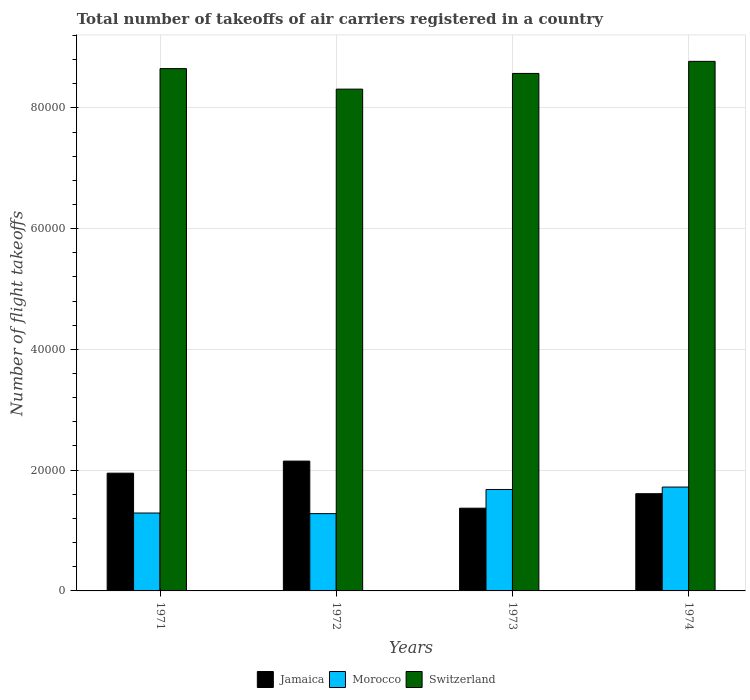How many groups of bars are there?
Provide a short and direct response. 4. Are the number of bars on each tick of the X-axis equal?
Provide a short and direct response. Yes. How many bars are there on the 2nd tick from the right?
Make the answer very short. 3. What is the label of the 2nd group of bars from the left?
Ensure brevity in your answer.  1972. What is the total number of flight takeoffs in Switzerland in 1972?
Offer a terse response. 8.31e+04. Across all years, what is the maximum total number of flight takeoffs in Morocco?
Give a very brief answer. 1.72e+04. Across all years, what is the minimum total number of flight takeoffs in Morocco?
Provide a succinct answer. 1.28e+04. In which year was the total number of flight takeoffs in Morocco maximum?
Provide a succinct answer. 1974. In which year was the total number of flight takeoffs in Jamaica minimum?
Your answer should be compact. 1973. What is the total total number of flight takeoffs in Morocco in the graph?
Offer a terse response. 5.97e+04. What is the difference between the total number of flight takeoffs in Morocco in 1971 and that in 1974?
Keep it short and to the point. -4300. What is the difference between the total number of flight takeoffs in Jamaica in 1974 and the total number of flight takeoffs in Switzerland in 1971?
Provide a succinct answer. -7.04e+04. What is the average total number of flight takeoffs in Jamaica per year?
Your answer should be compact. 1.77e+04. In the year 1971, what is the difference between the total number of flight takeoffs in Switzerland and total number of flight takeoffs in Jamaica?
Give a very brief answer. 6.70e+04. In how many years, is the total number of flight takeoffs in Switzerland greater than 8000?
Your answer should be compact. 4. What is the ratio of the total number of flight takeoffs in Jamaica in 1971 to that in 1974?
Your response must be concise. 1.21. Is the difference between the total number of flight takeoffs in Switzerland in 1971 and 1972 greater than the difference between the total number of flight takeoffs in Jamaica in 1971 and 1972?
Keep it short and to the point. Yes. What is the difference between the highest and the second highest total number of flight takeoffs in Switzerland?
Provide a succinct answer. 1200. What is the difference between the highest and the lowest total number of flight takeoffs in Jamaica?
Offer a very short reply. 7800. Is the sum of the total number of flight takeoffs in Morocco in 1971 and 1974 greater than the maximum total number of flight takeoffs in Jamaica across all years?
Your answer should be very brief. Yes. What does the 2nd bar from the left in 1974 represents?
Your answer should be very brief. Morocco. What does the 2nd bar from the right in 1971 represents?
Provide a succinct answer. Morocco. Is it the case that in every year, the sum of the total number of flight takeoffs in Switzerland and total number of flight takeoffs in Jamaica is greater than the total number of flight takeoffs in Morocco?
Your answer should be very brief. Yes. Are all the bars in the graph horizontal?
Make the answer very short. No. How many years are there in the graph?
Offer a terse response. 4. What is the difference between two consecutive major ticks on the Y-axis?
Ensure brevity in your answer.  2.00e+04. Does the graph contain any zero values?
Your response must be concise. No. Does the graph contain grids?
Offer a very short reply. Yes. How are the legend labels stacked?
Your answer should be compact. Horizontal. What is the title of the graph?
Make the answer very short. Total number of takeoffs of air carriers registered in a country. Does "Mongolia" appear as one of the legend labels in the graph?
Give a very brief answer. No. What is the label or title of the X-axis?
Keep it short and to the point. Years. What is the label or title of the Y-axis?
Keep it short and to the point. Number of flight takeoffs. What is the Number of flight takeoffs in Jamaica in 1971?
Offer a very short reply. 1.95e+04. What is the Number of flight takeoffs in Morocco in 1971?
Make the answer very short. 1.29e+04. What is the Number of flight takeoffs of Switzerland in 1971?
Offer a terse response. 8.65e+04. What is the Number of flight takeoffs in Jamaica in 1972?
Offer a very short reply. 2.15e+04. What is the Number of flight takeoffs in Morocco in 1972?
Make the answer very short. 1.28e+04. What is the Number of flight takeoffs of Switzerland in 1972?
Your answer should be very brief. 8.31e+04. What is the Number of flight takeoffs in Jamaica in 1973?
Ensure brevity in your answer.  1.37e+04. What is the Number of flight takeoffs in Morocco in 1973?
Your answer should be compact. 1.68e+04. What is the Number of flight takeoffs of Switzerland in 1973?
Your response must be concise. 8.57e+04. What is the Number of flight takeoffs of Jamaica in 1974?
Provide a short and direct response. 1.61e+04. What is the Number of flight takeoffs in Morocco in 1974?
Your answer should be compact. 1.72e+04. What is the Number of flight takeoffs of Switzerland in 1974?
Make the answer very short. 8.77e+04. Across all years, what is the maximum Number of flight takeoffs of Jamaica?
Ensure brevity in your answer.  2.15e+04. Across all years, what is the maximum Number of flight takeoffs of Morocco?
Give a very brief answer. 1.72e+04. Across all years, what is the maximum Number of flight takeoffs of Switzerland?
Offer a very short reply. 8.77e+04. Across all years, what is the minimum Number of flight takeoffs in Jamaica?
Provide a short and direct response. 1.37e+04. Across all years, what is the minimum Number of flight takeoffs of Morocco?
Offer a terse response. 1.28e+04. Across all years, what is the minimum Number of flight takeoffs of Switzerland?
Make the answer very short. 8.31e+04. What is the total Number of flight takeoffs of Jamaica in the graph?
Give a very brief answer. 7.08e+04. What is the total Number of flight takeoffs of Morocco in the graph?
Make the answer very short. 5.97e+04. What is the total Number of flight takeoffs of Switzerland in the graph?
Keep it short and to the point. 3.43e+05. What is the difference between the Number of flight takeoffs in Jamaica in 1971 and that in 1972?
Your answer should be very brief. -2000. What is the difference between the Number of flight takeoffs in Morocco in 1971 and that in 1972?
Ensure brevity in your answer.  100. What is the difference between the Number of flight takeoffs in Switzerland in 1971 and that in 1972?
Keep it short and to the point. 3400. What is the difference between the Number of flight takeoffs of Jamaica in 1971 and that in 1973?
Offer a terse response. 5800. What is the difference between the Number of flight takeoffs in Morocco in 1971 and that in 1973?
Keep it short and to the point. -3900. What is the difference between the Number of flight takeoffs in Switzerland in 1971 and that in 1973?
Provide a succinct answer. 800. What is the difference between the Number of flight takeoffs in Jamaica in 1971 and that in 1974?
Your answer should be very brief. 3400. What is the difference between the Number of flight takeoffs of Morocco in 1971 and that in 1974?
Keep it short and to the point. -4300. What is the difference between the Number of flight takeoffs of Switzerland in 1971 and that in 1974?
Make the answer very short. -1200. What is the difference between the Number of flight takeoffs of Jamaica in 1972 and that in 1973?
Make the answer very short. 7800. What is the difference between the Number of flight takeoffs of Morocco in 1972 and that in 1973?
Ensure brevity in your answer.  -4000. What is the difference between the Number of flight takeoffs of Switzerland in 1972 and that in 1973?
Keep it short and to the point. -2600. What is the difference between the Number of flight takeoffs in Jamaica in 1972 and that in 1974?
Keep it short and to the point. 5400. What is the difference between the Number of flight takeoffs in Morocco in 1972 and that in 1974?
Make the answer very short. -4400. What is the difference between the Number of flight takeoffs of Switzerland in 1972 and that in 1974?
Give a very brief answer. -4600. What is the difference between the Number of flight takeoffs of Jamaica in 1973 and that in 1974?
Provide a short and direct response. -2400. What is the difference between the Number of flight takeoffs of Morocco in 1973 and that in 1974?
Provide a short and direct response. -400. What is the difference between the Number of flight takeoffs in Switzerland in 1973 and that in 1974?
Ensure brevity in your answer.  -2000. What is the difference between the Number of flight takeoffs in Jamaica in 1971 and the Number of flight takeoffs in Morocco in 1972?
Give a very brief answer. 6700. What is the difference between the Number of flight takeoffs of Jamaica in 1971 and the Number of flight takeoffs of Switzerland in 1972?
Give a very brief answer. -6.36e+04. What is the difference between the Number of flight takeoffs of Morocco in 1971 and the Number of flight takeoffs of Switzerland in 1972?
Offer a very short reply. -7.02e+04. What is the difference between the Number of flight takeoffs in Jamaica in 1971 and the Number of flight takeoffs in Morocco in 1973?
Your answer should be compact. 2700. What is the difference between the Number of flight takeoffs in Jamaica in 1971 and the Number of flight takeoffs in Switzerland in 1973?
Offer a terse response. -6.62e+04. What is the difference between the Number of flight takeoffs of Morocco in 1971 and the Number of flight takeoffs of Switzerland in 1973?
Offer a very short reply. -7.28e+04. What is the difference between the Number of flight takeoffs in Jamaica in 1971 and the Number of flight takeoffs in Morocco in 1974?
Provide a succinct answer. 2300. What is the difference between the Number of flight takeoffs of Jamaica in 1971 and the Number of flight takeoffs of Switzerland in 1974?
Provide a short and direct response. -6.82e+04. What is the difference between the Number of flight takeoffs of Morocco in 1971 and the Number of flight takeoffs of Switzerland in 1974?
Offer a terse response. -7.48e+04. What is the difference between the Number of flight takeoffs of Jamaica in 1972 and the Number of flight takeoffs of Morocco in 1973?
Your answer should be very brief. 4700. What is the difference between the Number of flight takeoffs in Jamaica in 1972 and the Number of flight takeoffs in Switzerland in 1973?
Your response must be concise. -6.42e+04. What is the difference between the Number of flight takeoffs in Morocco in 1972 and the Number of flight takeoffs in Switzerland in 1973?
Your answer should be compact. -7.29e+04. What is the difference between the Number of flight takeoffs in Jamaica in 1972 and the Number of flight takeoffs in Morocco in 1974?
Your response must be concise. 4300. What is the difference between the Number of flight takeoffs of Jamaica in 1972 and the Number of flight takeoffs of Switzerland in 1974?
Give a very brief answer. -6.62e+04. What is the difference between the Number of flight takeoffs in Morocco in 1972 and the Number of flight takeoffs in Switzerland in 1974?
Provide a succinct answer. -7.49e+04. What is the difference between the Number of flight takeoffs of Jamaica in 1973 and the Number of flight takeoffs of Morocco in 1974?
Provide a succinct answer. -3500. What is the difference between the Number of flight takeoffs of Jamaica in 1973 and the Number of flight takeoffs of Switzerland in 1974?
Offer a very short reply. -7.40e+04. What is the difference between the Number of flight takeoffs of Morocco in 1973 and the Number of flight takeoffs of Switzerland in 1974?
Your response must be concise. -7.09e+04. What is the average Number of flight takeoffs of Jamaica per year?
Offer a terse response. 1.77e+04. What is the average Number of flight takeoffs in Morocco per year?
Offer a terse response. 1.49e+04. What is the average Number of flight takeoffs in Switzerland per year?
Provide a succinct answer. 8.58e+04. In the year 1971, what is the difference between the Number of flight takeoffs of Jamaica and Number of flight takeoffs of Morocco?
Your answer should be very brief. 6600. In the year 1971, what is the difference between the Number of flight takeoffs in Jamaica and Number of flight takeoffs in Switzerland?
Your response must be concise. -6.70e+04. In the year 1971, what is the difference between the Number of flight takeoffs of Morocco and Number of flight takeoffs of Switzerland?
Make the answer very short. -7.36e+04. In the year 1972, what is the difference between the Number of flight takeoffs of Jamaica and Number of flight takeoffs of Morocco?
Provide a succinct answer. 8700. In the year 1972, what is the difference between the Number of flight takeoffs of Jamaica and Number of flight takeoffs of Switzerland?
Make the answer very short. -6.16e+04. In the year 1972, what is the difference between the Number of flight takeoffs of Morocco and Number of flight takeoffs of Switzerland?
Your response must be concise. -7.03e+04. In the year 1973, what is the difference between the Number of flight takeoffs of Jamaica and Number of flight takeoffs of Morocco?
Ensure brevity in your answer.  -3100. In the year 1973, what is the difference between the Number of flight takeoffs in Jamaica and Number of flight takeoffs in Switzerland?
Offer a terse response. -7.20e+04. In the year 1973, what is the difference between the Number of flight takeoffs in Morocco and Number of flight takeoffs in Switzerland?
Provide a succinct answer. -6.89e+04. In the year 1974, what is the difference between the Number of flight takeoffs in Jamaica and Number of flight takeoffs in Morocco?
Your response must be concise. -1100. In the year 1974, what is the difference between the Number of flight takeoffs of Jamaica and Number of flight takeoffs of Switzerland?
Offer a terse response. -7.16e+04. In the year 1974, what is the difference between the Number of flight takeoffs of Morocco and Number of flight takeoffs of Switzerland?
Offer a terse response. -7.05e+04. What is the ratio of the Number of flight takeoffs of Jamaica in 1971 to that in 1972?
Your answer should be compact. 0.91. What is the ratio of the Number of flight takeoffs in Morocco in 1971 to that in 1972?
Give a very brief answer. 1.01. What is the ratio of the Number of flight takeoffs of Switzerland in 1971 to that in 1972?
Make the answer very short. 1.04. What is the ratio of the Number of flight takeoffs of Jamaica in 1971 to that in 1973?
Provide a succinct answer. 1.42. What is the ratio of the Number of flight takeoffs in Morocco in 1971 to that in 1973?
Provide a succinct answer. 0.77. What is the ratio of the Number of flight takeoffs in Switzerland in 1971 to that in 1973?
Your response must be concise. 1.01. What is the ratio of the Number of flight takeoffs in Jamaica in 1971 to that in 1974?
Ensure brevity in your answer.  1.21. What is the ratio of the Number of flight takeoffs in Morocco in 1971 to that in 1974?
Keep it short and to the point. 0.75. What is the ratio of the Number of flight takeoffs in Switzerland in 1971 to that in 1974?
Provide a short and direct response. 0.99. What is the ratio of the Number of flight takeoffs in Jamaica in 1972 to that in 1973?
Your answer should be compact. 1.57. What is the ratio of the Number of flight takeoffs of Morocco in 1972 to that in 1973?
Your answer should be very brief. 0.76. What is the ratio of the Number of flight takeoffs of Switzerland in 1972 to that in 1973?
Make the answer very short. 0.97. What is the ratio of the Number of flight takeoffs in Jamaica in 1972 to that in 1974?
Your answer should be compact. 1.34. What is the ratio of the Number of flight takeoffs of Morocco in 1972 to that in 1974?
Offer a terse response. 0.74. What is the ratio of the Number of flight takeoffs in Switzerland in 1972 to that in 1974?
Ensure brevity in your answer.  0.95. What is the ratio of the Number of flight takeoffs in Jamaica in 1973 to that in 1974?
Ensure brevity in your answer.  0.85. What is the ratio of the Number of flight takeoffs of Morocco in 1973 to that in 1974?
Your answer should be very brief. 0.98. What is the ratio of the Number of flight takeoffs in Switzerland in 1973 to that in 1974?
Provide a short and direct response. 0.98. What is the difference between the highest and the second highest Number of flight takeoffs of Switzerland?
Your response must be concise. 1200. What is the difference between the highest and the lowest Number of flight takeoffs in Jamaica?
Keep it short and to the point. 7800. What is the difference between the highest and the lowest Number of flight takeoffs in Morocco?
Keep it short and to the point. 4400. What is the difference between the highest and the lowest Number of flight takeoffs of Switzerland?
Offer a terse response. 4600. 